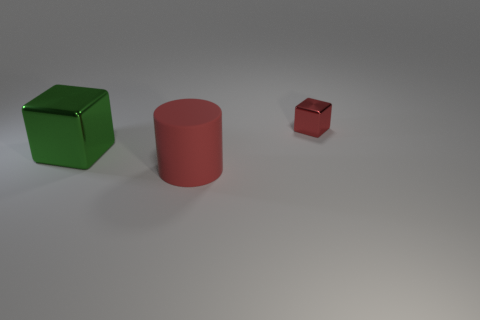Add 2 yellow rubber spheres. How many objects exist? 5 Subtract all red blocks. How many blocks are left? 1 Subtract all cylinders. How many objects are left? 2 Subtract all gray cubes. Subtract all green spheres. How many cubes are left? 2 Subtract all cyan balls. How many cyan cylinders are left? 0 Subtract all big red matte objects. Subtract all big cylinders. How many objects are left? 1 Add 3 red metal things. How many red metal things are left? 4 Add 1 large green blocks. How many large green blocks exist? 2 Subtract 1 red cylinders. How many objects are left? 2 